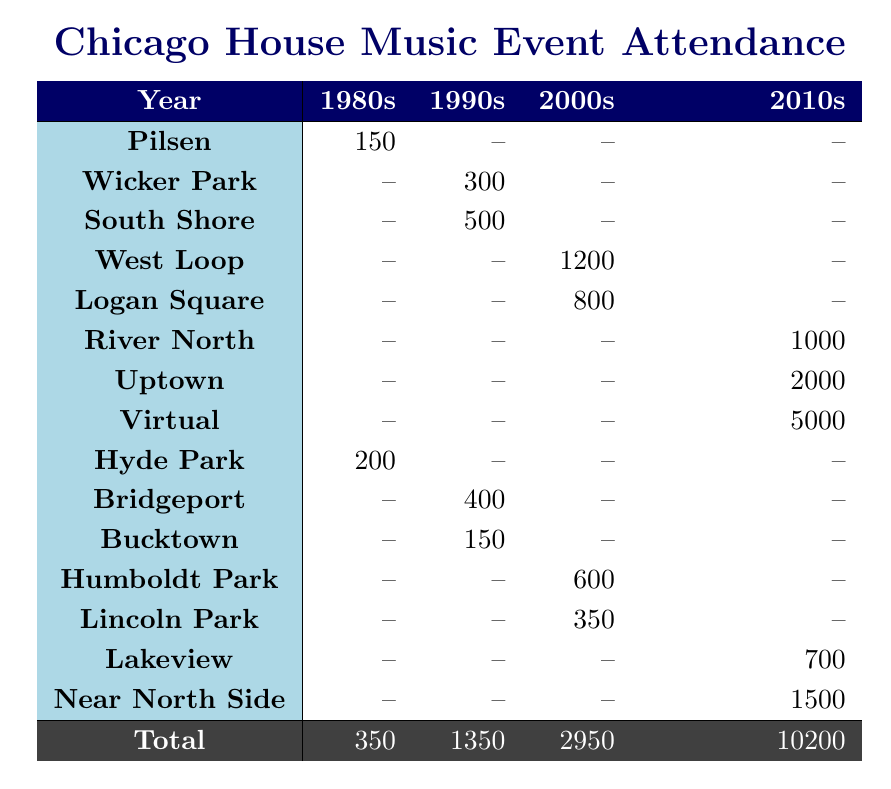What was the total attendance for events in the 1980s? The table shows the attendance for the 1980s, which includes events from Pilsen (150), Hyde Park (200), and a total of 350. To find the total, simply sum these figures: 150 + 200 = 350.
Answer: 350 Which neighborhood had the highest attendance in the 2000s? Looking at the 2000s column, West Loop had an attendance of 1200, Logan Square 800, and Humboldt Park 600. The highest attendance therefore is 1200 from West Loop.
Answer: West Loop Did any events in the 1990s have attendance of more than 400? In the 1990s, attendance figures are as follows: Wicker Park (300), South Shore (500), Bridgeport (400), and Bucktown (150). Since South Shore had an attendance of 500, which is greater than 400, the answer is yes.
Answer: Yes What was the average attendance across all events in the 2010s? There were three events in the 2010s: River North (1000), Uptown (2000), and Near North Side (1500). To find the average attendance, sum the attendance (1000 + 2000 + 1500 = 4500) and divide by the number of events (3): 4500 / 3 = 1500.
Answer: 1500 Which neighborhood saw a significant growth in attendance from the 1980s to the 2010s? We can analyze attendance from Pilsen (150 in 1985) to Uptown (2000 in 2015), which shows a significant growth. Pilsen's attendance doesn't grow in the 2010s, and Uptown is the only neighborhood mentioned. Hence, Uptown clearly shows significant growth.
Answer: Uptown In which year did virtual events start? Virtual events are listed under the neighborhood "Virtual" with the attendance of 5000 in 2020. By checking other neighborhoods, there are no virtual events listed prior to 2020, confirming that virtual events started in 2020.
Answer: 2020 What is the difference in total attendance between the 1990s and 2000s? The total attendance for the 1990s sums up to 1350 (300 + 500 + 400 + 150), while the 2000s sum is 2950 (1200 + 800 + 600 + 350). The difference is 2950 - 1350 = 1600.
Answer: 1600 Did attendance for every event in the 1980s increase compared to its previous decade? The 1980s attendance shows figures solely from this decade and has no previous decade data for comparison. Events from the 1980s cannot be assessed against any prior data. Therefore, it is not feasible to determine any increase.
Answer: No 